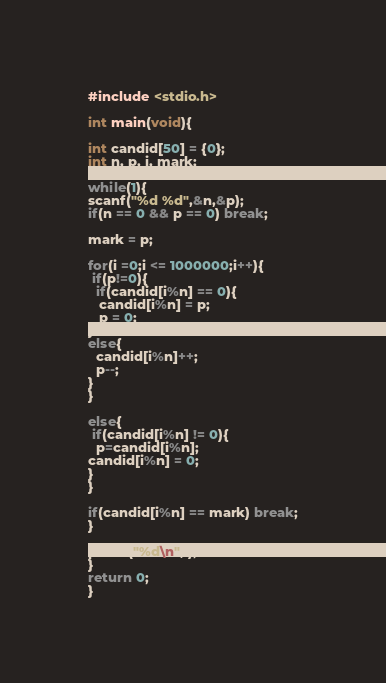<code> <loc_0><loc_0><loc_500><loc_500><_C_>#include <stdio.h>

int main(void){

int candid[50] = {0};
int n, p, i, mark;

while(1){
scanf("%d %d",&n,&p);
if(n == 0 && p == 0) break;

mark = p;

for(i =0;i <= 1000000;i++){
 if(p!=0){
  if(candid[i%n] == 0){
   candid[i%n] = p;
   p = 0;
}
else{
  candid[i%n]++;
  p--;
}
}

else{
 if(candid[i%n] != 0){
  p=candid[i%n];
candid[i%n] = 0;
}
}

if(candid[i%n] == mark) break;
}

printf("%d\n",i);
}
return 0;
}</code> 